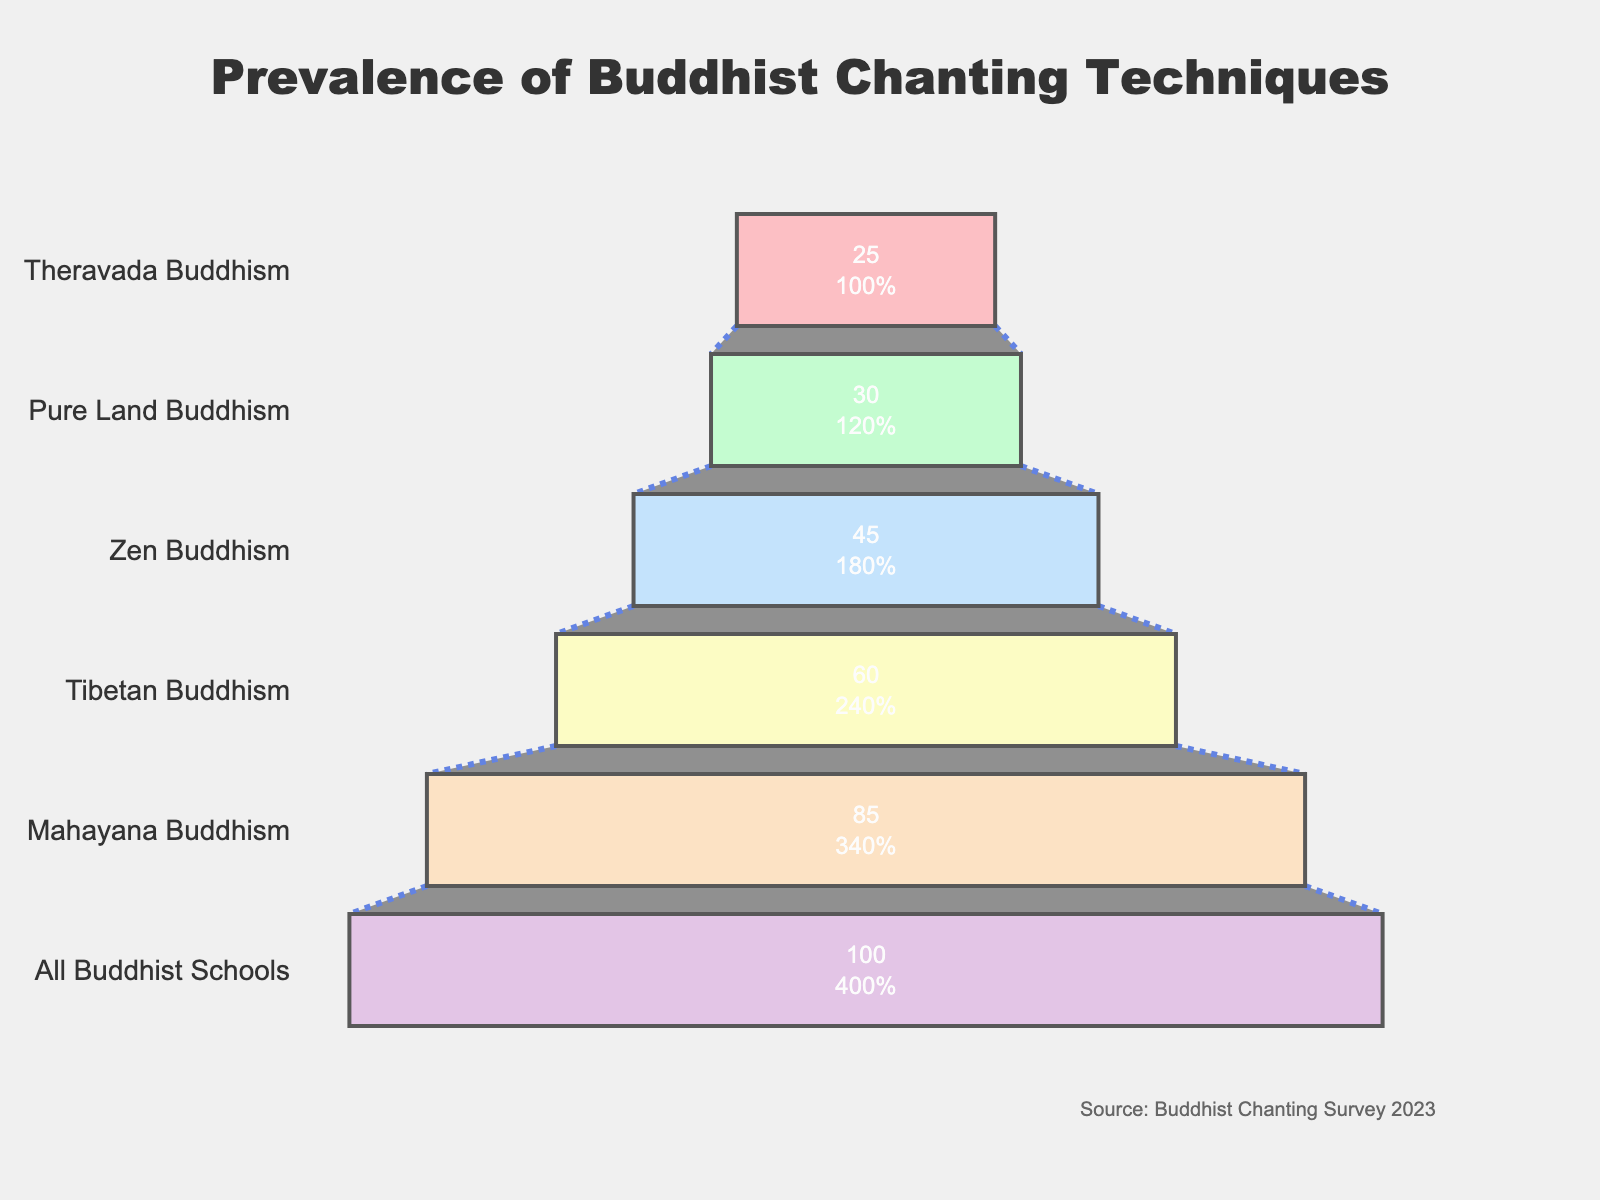What is the title of the funnel chart? The title can be found at the top of the funnel chart, typically in a larger font size than other text elements.
Answer: Prevalence of Buddhist Chanting Techniques Which chanting technique is most prevalent in all Buddhist schools according to the chart? The widest section at the top of the funnel represents the technique with the highest prevalence.
Answer: Basic Monotone Chanting How many different chanting techniques are displayed in the chart? Count the number of distinct stages in the funnel chart.
Answer: 6 Which Buddhist school has the least prevalent chanting technique according to the chart? The narrowest section at the bottom of the funnel indicates the chanting technique with the lowest prevalence.
Answer: Theravada Buddhism What percentage of schools use Pali Canon Rhythmic Chanting? Locate the section labeled "Pali Canon Rhythmic Chanting" and read the associated percentage value.
Answer: 25% What is the difference in prevalence between Melody-based Chanting and Nembutsu Repetition? Subtract the percentage of Nembutsu Repetition from the percentage of Melody-based Chanting. 85% - 30% = 55%
Answer: 55% Which chanting technique is unique to Tibetan Buddhism, and how prevalent is it? Identify the section labeled with a technique specific to Tibetan Buddhism and note its percentage.
Answer: Multiphonic Chanting, 60% Compare the prevalence of Sutra Tonal Recitation in Zen Buddhism to Nembutsu Repetition in Pure Land Buddhism. Which is more prevalent? Identify both techniques and compare their percentage values. Sutra Tonal Recitation has 45%, whereas Nembutsu Repetition has 30%.
Answer: Sutra Tonal Recitation How much more prevalent is Basic Monotone Chanting compared to Pali Canon Rhythmic Chanting? Subtract the percentage of Pali Canon Rhythmic Chanting from Basic Monotone Chanting. 100% - 25% = 75%
Answer: 75% Determine the average prevalence percentage of all chanting techniques. Add up all the percentages and divide by the number of techniques. (100 + 85 + 60 + 45 + 30 + 25) / 6 = 345 / 6 = 57.5%
Answer: 57.5% 